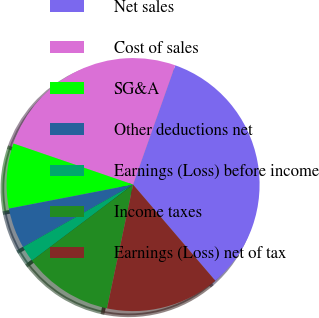Convert chart to OTSL. <chart><loc_0><loc_0><loc_500><loc_500><pie_chart><fcel>Net sales<fcel>Cost of sales<fcel>SG&A<fcel>Other deductions net<fcel>Earnings (Loss) before income<fcel>Income taxes<fcel>Earnings (Loss) net of tax<nl><fcel>33.33%<fcel>25.14%<fcel>8.3%<fcel>5.18%<fcel>2.05%<fcel>11.43%<fcel>14.56%<nl></chart> 